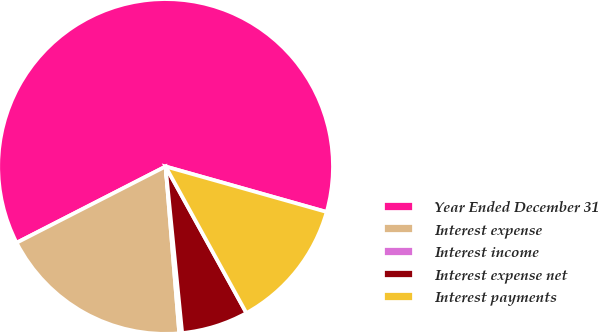<chart> <loc_0><loc_0><loc_500><loc_500><pie_chart><fcel>Year Ended December 31<fcel>Interest expense<fcel>Interest income<fcel>Interest expense net<fcel>Interest payments<nl><fcel>61.91%<fcel>18.77%<fcel>0.28%<fcel>6.44%<fcel>12.6%<nl></chart> 